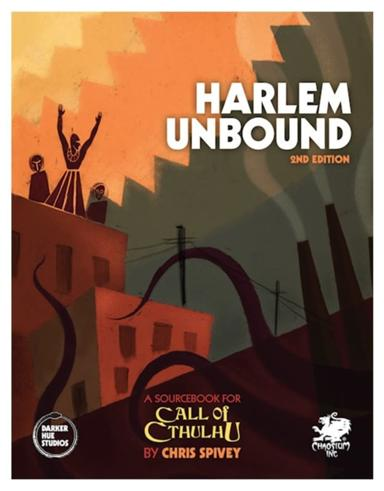What is Harlem Unbound? 'Harlem Unbound' is a groundbreaking sourcebook for the 'Call of Cthulhu' role-playing game, authored by Chris Spivey. Set amidst the vibrant and culturally rich period of the Harlem Renaissance, this book combines historical accuracies with mythic horror elements. It offers players a unique narrative experience, supplying intense, thematic scenarios and diverse character options that reflect the racial and cultural milieu of 1920s Harlem. 